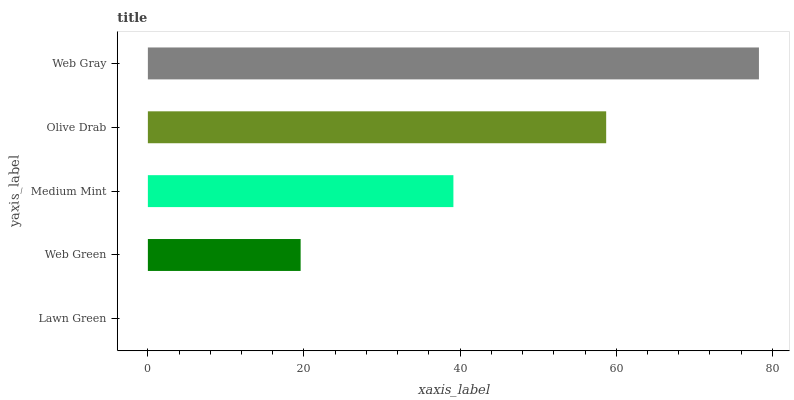Is Lawn Green the minimum?
Answer yes or no. Yes. Is Web Gray the maximum?
Answer yes or no. Yes. Is Web Green the minimum?
Answer yes or no. No. Is Web Green the maximum?
Answer yes or no. No. Is Web Green greater than Lawn Green?
Answer yes or no. Yes. Is Lawn Green less than Web Green?
Answer yes or no. Yes. Is Lawn Green greater than Web Green?
Answer yes or no. No. Is Web Green less than Lawn Green?
Answer yes or no. No. Is Medium Mint the high median?
Answer yes or no. Yes. Is Medium Mint the low median?
Answer yes or no. Yes. Is Olive Drab the high median?
Answer yes or no. No. Is Lawn Green the low median?
Answer yes or no. No. 